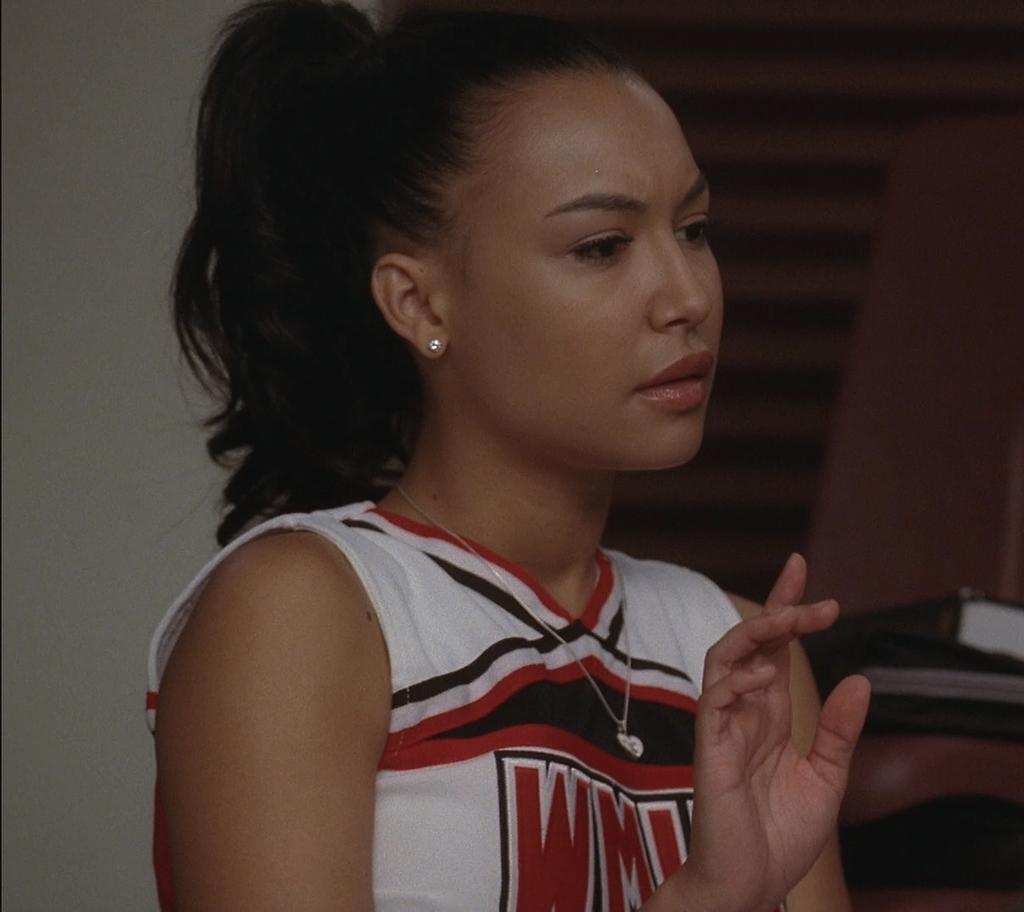<image>
Write a terse but informative summary of the picture. Black, red, and white cheer uniform with letters WM wrote in red. 